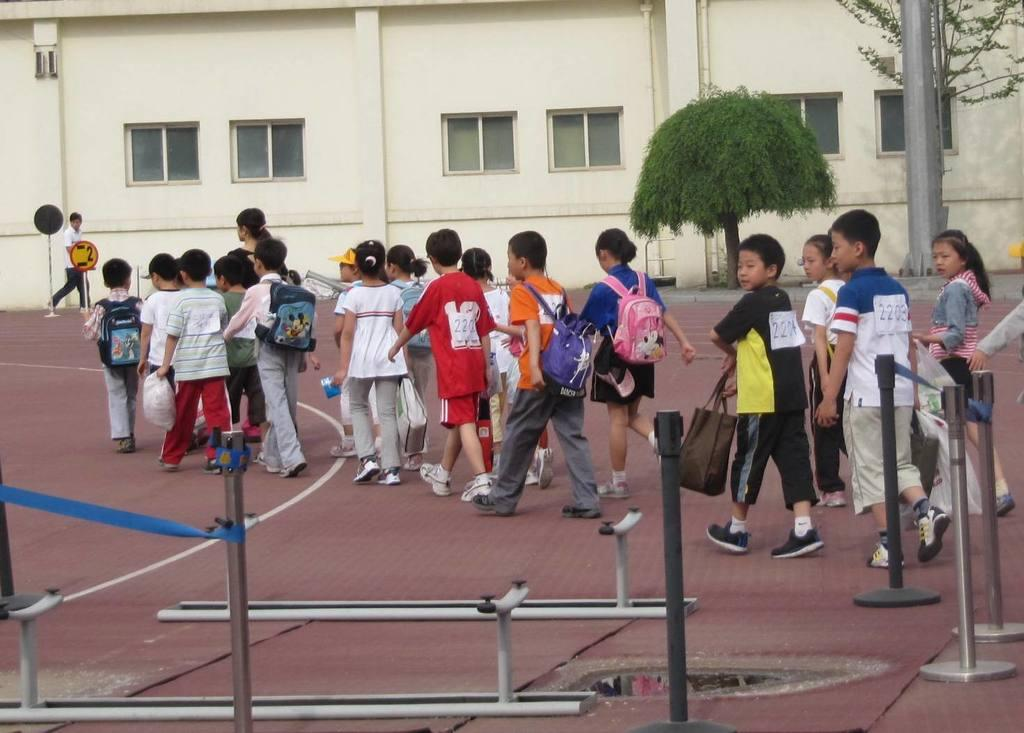How many people are in the image? There is a group of people in the image, but the exact number cannot be determined from the provided facts. What objects are present in the image besides the people? There are poles, boards, and trees visible in the image. What can be seen in the background of the image? There is a building and windows visible in the background of the image. What type of icicle can be seen hanging from the building in the image? There is no icicle present in the image; it is not cold enough for icicles to form. Can you tell me how many cribs are visible in the image? There are no cribs present in the image. 